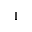Convert formula to latex. <formula><loc_0><loc_0><loc_500><loc_500>I</formula> 